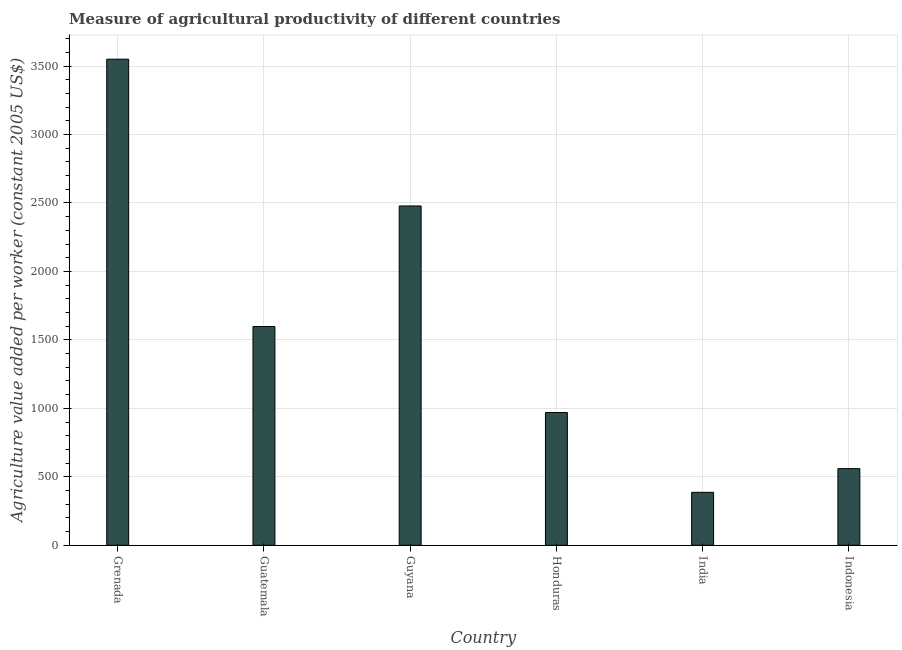Does the graph contain any zero values?
Ensure brevity in your answer.  No. What is the title of the graph?
Make the answer very short. Measure of agricultural productivity of different countries. What is the label or title of the X-axis?
Make the answer very short. Country. What is the label or title of the Y-axis?
Offer a terse response. Agriculture value added per worker (constant 2005 US$). What is the agriculture value added per worker in Honduras?
Keep it short and to the point. 969.6. Across all countries, what is the maximum agriculture value added per worker?
Give a very brief answer. 3550.21. Across all countries, what is the minimum agriculture value added per worker?
Offer a terse response. 386.77. In which country was the agriculture value added per worker maximum?
Your answer should be very brief. Grenada. What is the sum of the agriculture value added per worker?
Your answer should be compact. 9542.29. What is the difference between the agriculture value added per worker in Guatemala and Indonesia?
Provide a succinct answer. 1037.65. What is the average agriculture value added per worker per country?
Ensure brevity in your answer.  1590.38. What is the median agriculture value added per worker?
Give a very brief answer. 1283.58. What is the ratio of the agriculture value added per worker in Honduras to that in Indonesia?
Your answer should be compact. 1.73. Is the difference between the agriculture value added per worker in India and Indonesia greater than the difference between any two countries?
Provide a succinct answer. No. What is the difference between the highest and the second highest agriculture value added per worker?
Provide a succinct answer. 1071.98. Is the sum of the agriculture value added per worker in India and Indonesia greater than the maximum agriculture value added per worker across all countries?
Give a very brief answer. No. What is the difference between the highest and the lowest agriculture value added per worker?
Keep it short and to the point. 3163.44. Are all the bars in the graph horizontal?
Give a very brief answer. No. Are the values on the major ticks of Y-axis written in scientific E-notation?
Provide a short and direct response. No. What is the Agriculture value added per worker (constant 2005 US$) in Grenada?
Offer a very short reply. 3550.21. What is the Agriculture value added per worker (constant 2005 US$) of Guatemala?
Make the answer very short. 1597.56. What is the Agriculture value added per worker (constant 2005 US$) in Guyana?
Offer a terse response. 2478.23. What is the Agriculture value added per worker (constant 2005 US$) of Honduras?
Your response must be concise. 969.6. What is the Agriculture value added per worker (constant 2005 US$) in India?
Your response must be concise. 386.77. What is the Agriculture value added per worker (constant 2005 US$) in Indonesia?
Offer a terse response. 559.91. What is the difference between the Agriculture value added per worker (constant 2005 US$) in Grenada and Guatemala?
Give a very brief answer. 1952.65. What is the difference between the Agriculture value added per worker (constant 2005 US$) in Grenada and Guyana?
Your answer should be compact. 1071.98. What is the difference between the Agriculture value added per worker (constant 2005 US$) in Grenada and Honduras?
Make the answer very short. 2580.61. What is the difference between the Agriculture value added per worker (constant 2005 US$) in Grenada and India?
Your answer should be very brief. 3163.44. What is the difference between the Agriculture value added per worker (constant 2005 US$) in Grenada and Indonesia?
Provide a short and direct response. 2990.3. What is the difference between the Agriculture value added per worker (constant 2005 US$) in Guatemala and Guyana?
Ensure brevity in your answer.  -880.67. What is the difference between the Agriculture value added per worker (constant 2005 US$) in Guatemala and Honduras?
Give a very brief answer. 627.96. What is the difference between the Agriculture value added per worker (constant 2005 US$) in Guatemala and India?
Give a very brief answer. 1210.79. What is the difference between the Agriculture value added per worker (constant 2005 US$) in Guatemala and Indonesia?
Offer a very short reply. 1037.65. What is the difference between the Agriculture value added per worker (constant 2005 US$) in Guyana and Honduras?
Offer a very short reply. 1508.63. What is the difference between the Agriculture value added per worker (constant 2005 US$) in Guyana and India?
Make the answer very short. 2091.46. What is the difference between the Agriculture value added per worker (constant 2005 US$) in Guyana and Indonesia?
Give a very brief answer. 1918.32. What is the difference between the Agriculture value added per worker (constant 2005 US$) in Honduras and India?
Make the answer very short. 582.83. What is the difference between the Agriculture value added per worker (constant 2005 US$) in Honduras and Indonesia?
Give a very brief answer. 409.69. What is the difference between the Agriculture value added per worker (constant 2005 US$) in India and Indonesia?
Offer a very short reply. -173.14. What is the ratio of the Agriculture value added per worker (constant 2005 US$) in Grenada to that in Guatemala?
Your response must be concise. 2.22. What is the ratio of the Agriculture value added per worker (constant 2005 US$) in Grenada to that in Guyana?
Ensure brevity in your answer.  1.43. What is the ratio of the Agriculture value added per worker (constant 2005 US$) in Grenada to that in Honduras?
Your response must be concise. 3.66. What is the ratio of the Agriculture value added per worker (constant 2005 US$) in Grenada to that in India?
Give a very brief answer. 9.18. What is the ratio of the Agriculture value added per worker (constant 2005 US$) in Grenada to that in Indonesia?
Give a very brief answer. 6.34. What is the ratio of the Agriculture value added per worker (constant 2005 US$) in Guatemala to that in Guyana?
Provide a succinct answer. 0.65. What is the ratio of the Agriculture value added per worker (constant 2005 US$) in Guatemala to that in Honduras?
Ensure brevity in your answer.  1.65. What is the ratio of the Agriculture value added per worker (constant 2005 US$) in Guatemala to that in India?
Keep it short and to the point. 4.13. What is the ratio of the Agriculture value added per worker (constant 2005 US$) in Guatemala to that in Indonesia?
Make the answer very short. 2.85. What is the ratio of the Agriculture value added per worker (constant 2005 US$) in Guyana to that in Honduras?
Give a very brief answer. 2.56. What is the ratio of the Agriculture value added per worker (constant 2005 US$) in Guyana to that in India?
Provide a short and direct response. 6.41. What is the ratio of the Agriculture value added per worker (constant 2005 US$) in Guyana to that in Indonesia?
Make the answer very short. 4.43. What is the ratio of the Agriculture value added per worker (constant 2005 US$) in Honduras to that in India?
Provide a succinct answer. 2.51. What is the ratio of the Agriculture value added per worker (constant 2005 US$) in Honduras to that in Indonesia?
Provide a short and direct response. 1.73. What is the ratio of the Agriculture value added per worker (constant 2005 US$) in India to that in Indonesia?
Provide a short and direct response. 0.69. 